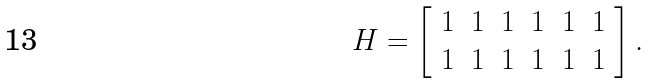Convert formula to latex. <formula><loc_0><loc_0><loc_500><loc_500>H = \left [ \begin{array} { c c c c c c } 1 & 1 & 1 & 1 & 1 & 1 \\ 1 & 1 & 1 & 1 & 1 & 1 \end{array} \right ] .</formula> 